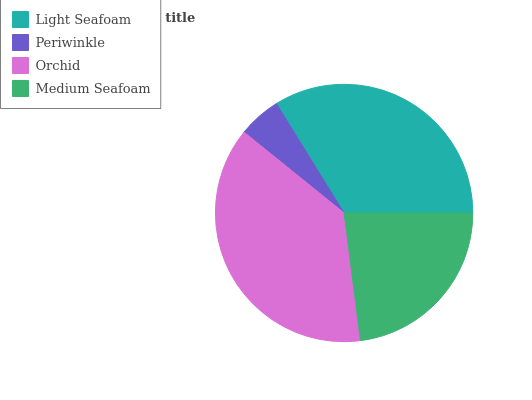Is Periwinkle the minimum?
Answer yes or no. Yes. Is Orchid the maximum?
Answer yes or no. Yes. Is Orchid the minimum?
Answer yes or no. No. Is Periwinkle the maximum?
Answer yes or no. No. Is Orchid greater than Periwinkle?
Answer yes or no. Yes. Is Periwinkle less than Orchid?
Answer yes or no. Yes. Is Periwinkle greater than Orchid?
Answer yes or no. No. Is Orchid less than Periwinkle?
Answer yes or no. No. Is Light Seafoam the high median?
Answer yes or no. Yes. Is Medium Seafoam the low median?
Answer yes or no. Yes. Is Medium Seafoam the high median?
Answer yes or no. No. Is Orchid the low median?
Answer yes or no. No. 